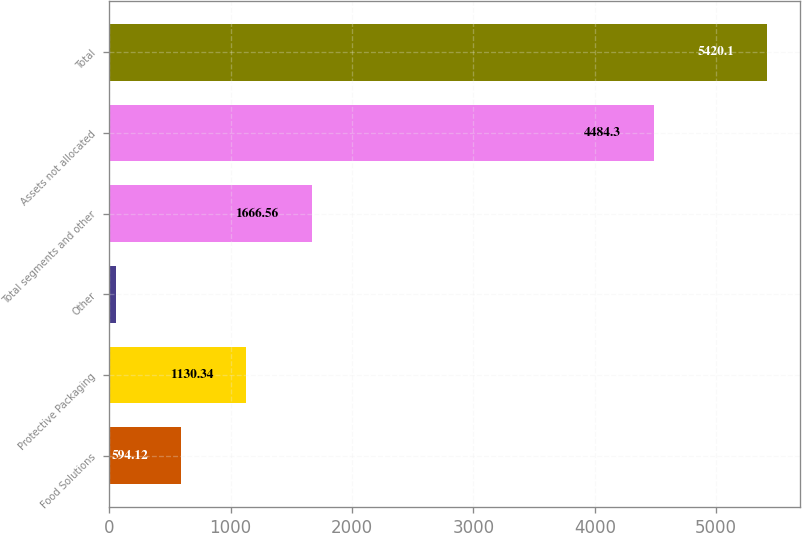Convert chart. <chart><loc_0><loc_0><loc_500><loc_500><bar_chart><fcel>Food Solutions<fcel>Protective Packaging<fcel>Other<fcel>Total segments and other<fcel>Assets not allocated<fcel>Total<nl><fcel>594.12<fcel>1130.34<fcel>57.9<fcel>1666.56<fcel>4484.3<fcel>5420.1<nl></chart> 